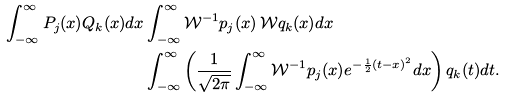<formula> <loc_0><loc_0><loc_500><loc_500>\int _ { - \infty } ^ { \infty } P _ { j } ( x ) Q _ { k } ( x ) d x & \int _ { - \infty } ^ { \infty } \mathcal { W } ^ { - 1 } p _ { j } ( x ) \, \mathcal { W } q _ { k } ( x ) d x \\ & \int _ { - \infty } ^ { \infty } \left ( \frac { 1 } { \sqrt { 2 \pi } } \int _ { - \infty } ^ { \infty } \mathcal { W } ^ { - 1 } p _ { j } ( x ) e ^ { - \frac { 1 } { 2 } ( t - x ) ^ { 2 } } d x \right ) q _ { k } ( t ) d t .</formula> 